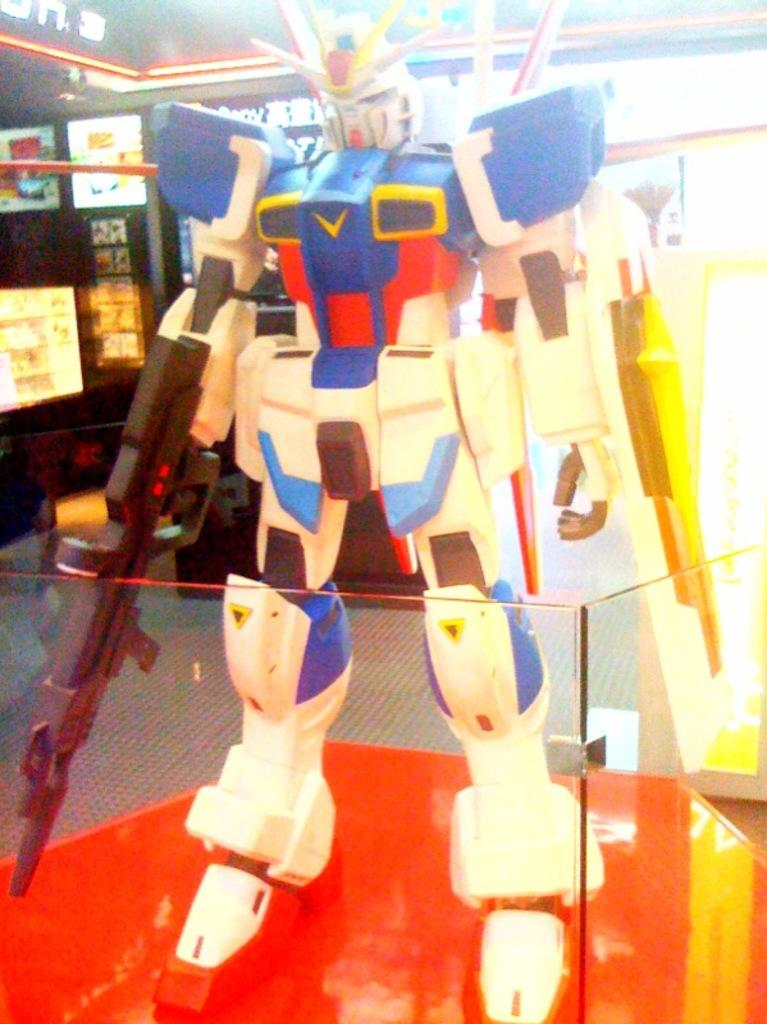What object is the main focus of the image? There is a toy robot in the image. What else can be seen in the background of the image? There are lights visible in the background of the image. What type of authority figure is present in the image? There is no authority figure present in the image; it focuses on a toy robot and lights in the background. 